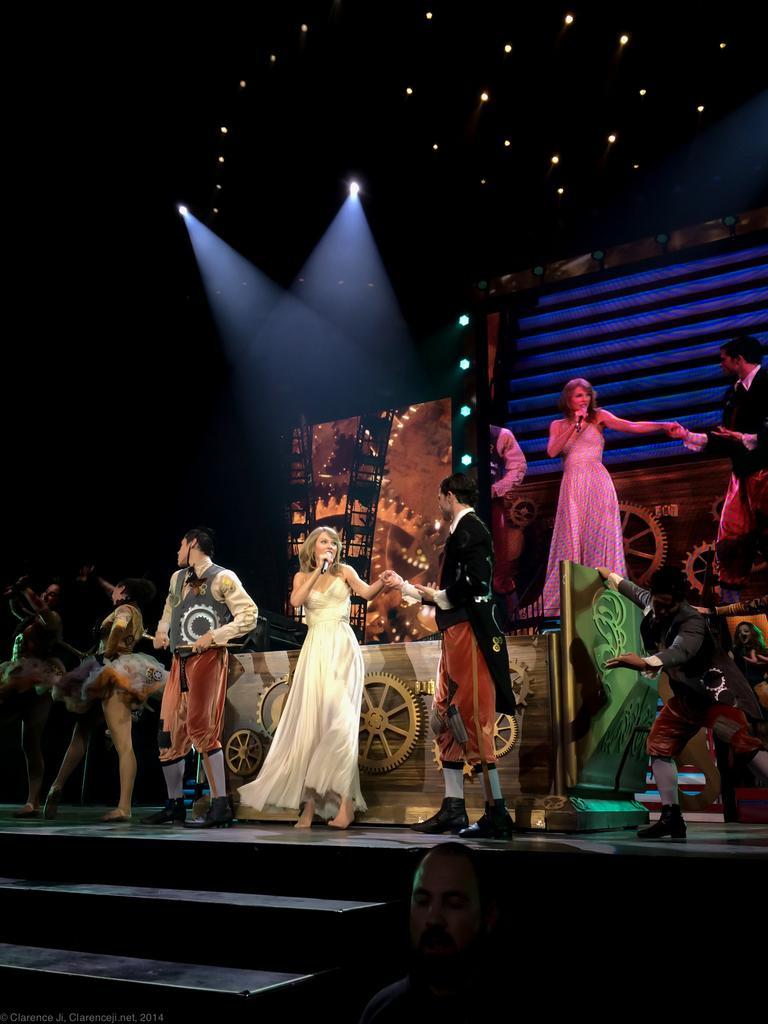How would you summarize this image in a sentence or two? In this image there are some persons standing on the stage and the person standing in middle is wearing white color dress and holding a Mic and right side to him there is one person standing is wearing black color dress and there are some lights arranged at top of this image and middle of this image and There is a screen at top right side of this image and there are some stairs at bottom left side of this image and there is one person standing at bottom of this image. 